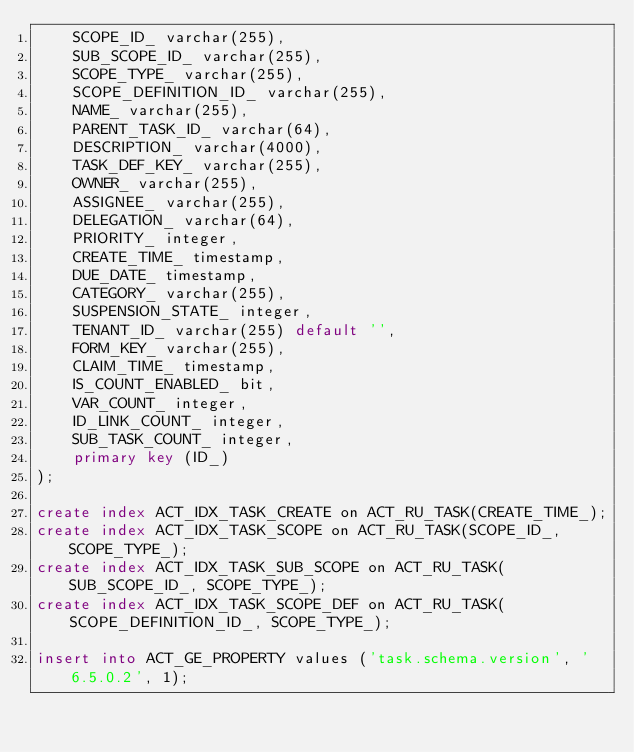<code> <loc_0><loc_0><loc_500><loc_500><_SQL_>    SCOPE_ID_ varchar(255),
    SUB_SCOPE_ID_ varchar(255),
    SCOPE_TYPE_ varchar(255),
    SCOPE_DEFINITION_ID_ varchar(255),
    NAME_ varchar(255),
    PARENT_TASK_ID_ varchar(64),
    DESCRIPTION_ varchar(4000),
    TASK_DEF_KEY_ varchar(255),
    OWNER_ varchar(255),
    ASSIGNEE_ varchar(255),
    DELEGATION_ varchar(64),
    PRIORITY_ integer,
    CREATE_TIME_ timestamp,
    DUE_DATE_ timestamp,
    CATEGORY_ varchar(255),
    SUSPENSION_STATE_ integer,
    TENANT_ID_ varchar(255) default '',
    FORM_KEY_ varchar(255),
    CLAIM_TIME_ timestamp,
    IS_COUNT_ENABLED_ bit,
    VAR_COUNT_ integer, 
    ID_LINK_COUNT_ integer,
    SUB_TASK_COUNT_ integer,
    primary key (ID_)
);

create index ACT_IDX_TASK_CREATE on ACT_RU_TASK(CREATE_TIME_);
create index ACT_IDX_TASK_SCOPE on ACT_RU_TASK(SCOPE_ID_, SCOPE_TYPE_);
create index ACT_IDX_TASK_SUB_SCOPE on ACT_RU_TASK(SUB_SCOPE_ID_, SCOPE_TYPE_);
create index ACT_IDX_TASK_SCOPE_DEF on ACT_RU_TASK(SCOPE_DEFINITION_ID_, SCOPE_TYPE_);

insert into ACT_GE_PROPERTY values ('task.schema.version', '6.5.0.2', 1);</code> 